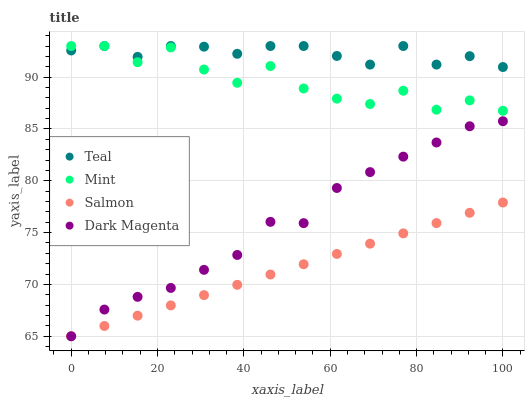Does Salmon have the minimum area under the curve?
Answer yes or no. Yes. Does Teal have the maximum area under the curve?
Answer yes or no. Yes. Does Mint have the minimum area under the curve?
Answer yes or no. No. Does Mint have the maximum area under the curve?
Answer yes or no. No. Is Salmon the smoothest?
Answer yes or no. Yes. Is Mint the roughest?
Answer yes or no. Yes. Is Dark Magenta the smoothest?
Answer yes or no. No. Is Dark Magenta the roughest?
Answer yes or no. No. Does Salmon have the lowest value?
Answer yes or no. Yes. Does Mint have the lowest value?
Answer yes or no. No. Does Teal have the highest value?
Answer yes or no. Yes. Does Dark Magenta have the highest value?
Answer yes or no. No. Is Salmon less than Mint?
Answer yes or no. Yes. Is Mint greater than Salmon?
Answer yes or no. Yes. Does Mint intersect Teal?
Answer yes or no. Yes. Is Mint less than Teal?
Answer yes or no. No. Is Mint greater than Teal?
Answer yes or no. No. Does Salmon intersect Mint?
Answer yes or no. No. 